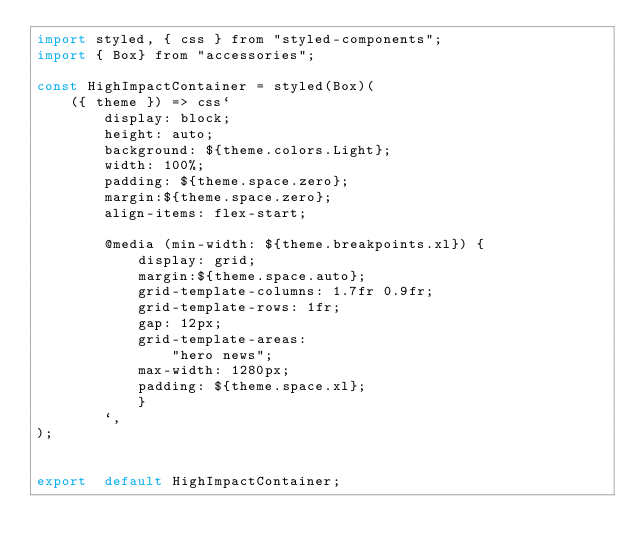<code> <loc_0><loc_0><loc_500><loc_500><_JavaScript_>import styled, { css } from "styled-components";
import { Box} from "accessories";

const HighImpactContainer = styled(Box)(
    ({ theme }) => css`
        display: block;
        height: auto;
        background: ${theme.colors.Light};
        width: 100%;
        padding: ${theme.space.zero}; 
        margin:${theme.space.zero}; 
        align-items: flex-start;

        @media (min-width: ${theme.breakpoints.xl}) {
            display: grid; 
            margin:${theme.space.auto}; 
            grid-template-columns: 1.7fr 0.9fr; 
            grid-template-rows: 1fr; 
            gap: 12px; 
            grid-template-areas: 
                "hero news"; 
            max-width: 1280px;
            padding: ${theme.space.xl};
            }   
        `,
);


export  default HighImpactContainer;
</code> 